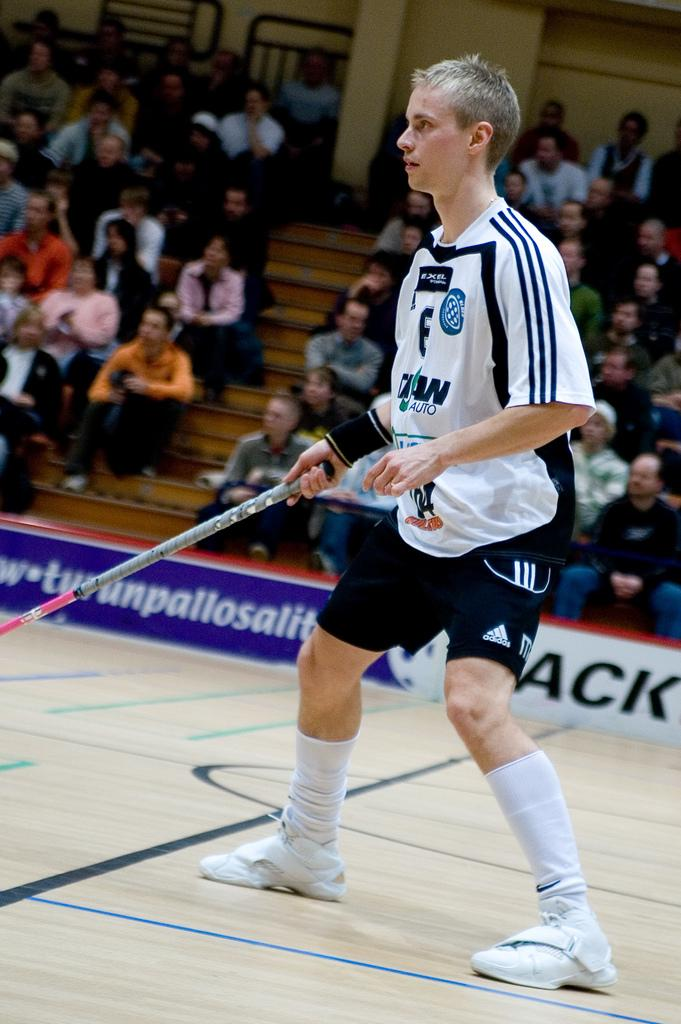How many people are in the image? There is a group of people in the image. What are some of the people in the image doing? Some of the people are seated. What is in front of the group of people? There is a hoarding in front of the group of people. Can you describe the man in the middle of the image? The man in the middle of the image is holding a stick. What type of stick does the man's father use to bite in the image? There is no father or biting stick present in the image. 